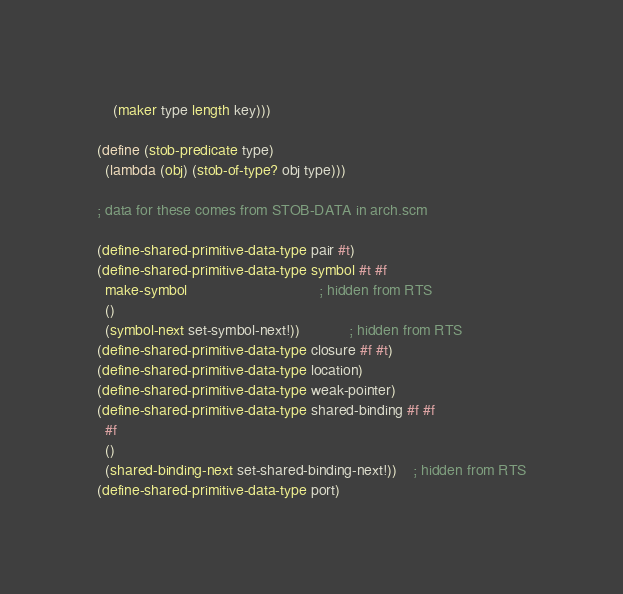<code> <loc_0><loc_0><loc_500><loc_500><_Scheme_>    (maker type length key)))

(define (stob-predicate type)
  (lambda (obj) (stob-of-type? obj type)))

; data for these comes from STOB-DATA in arch.scm

(define-shared-primitive-data-type pair #t)
(define-shared-primitive-data-type symbol #t #f
  make-symbol                           		; hidden from RTS
  ()
  (symbol-next set-symbol-next!))       		; hidden from RTS
(define-shared-primitive-data-type closure #f #t)
(define-shared-primitive-data-type location)
(define-shared-primitive-data-type weak-pointer)
(define-shared-primitive-data-type shared-binding #f #f
  #f
  ()
  (shared-binding-next set-shared-binding-next!))	; hidden from RTS
(define-shared-primitive-data-type port)</code> 